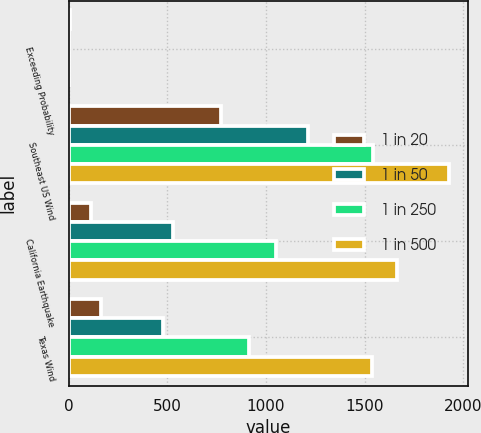<chart> <loc_0><loc_0><loc_500><loc_500><stacked_bar_chart><ecel><fcel>Exceeding Probability<fcel>Southeast US Wind<fcel>California Earthquake<fcel>Texas Wind<nl><fcel>1 in 20<fcel>5<fcel>771<fcel>113<fcel>165<nl><fcel>1 in 50<fcel>2<fcel>1213<fcel>527<fcel>477<nl><fcel>1 in 250<fcel>1<fcel>1544<fcel>1050<fcel>915<nl><fcel>1 in 500<fcel>0.4<fcel>1929<fcel>1665<fcel>1539<nl></chart> 